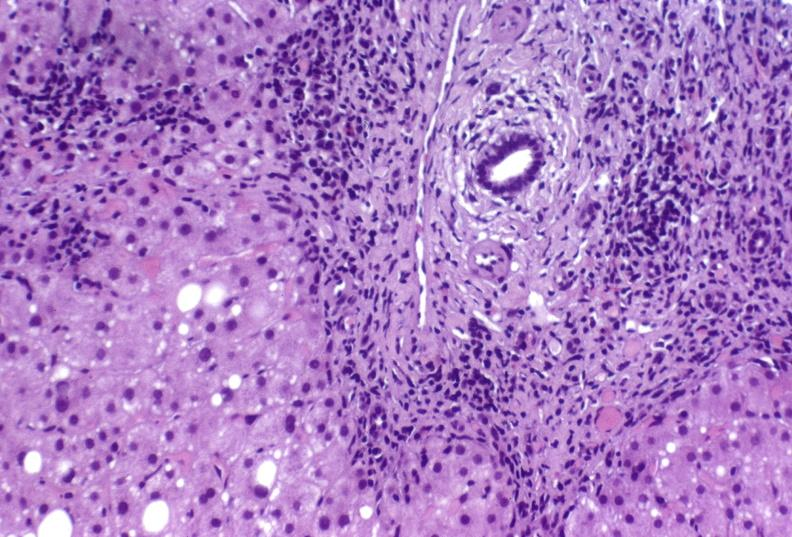what is present?
Answer the question using a single word or phrase. Liver 